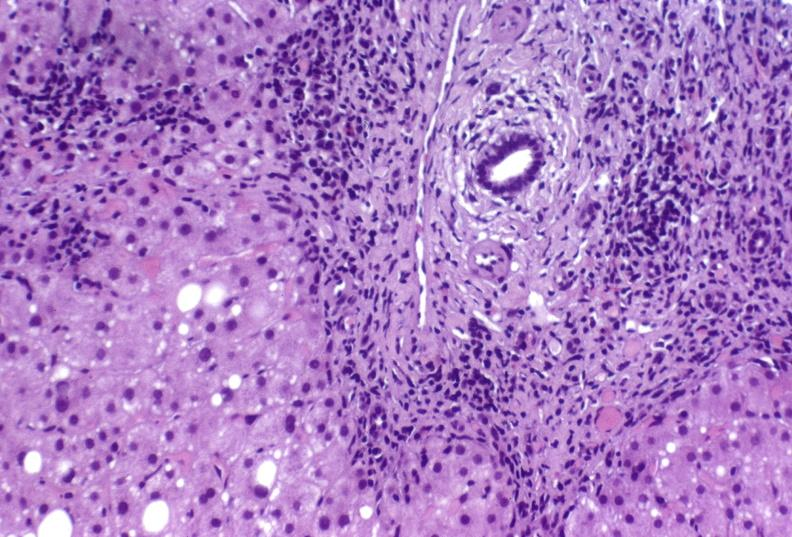what is present?
Answer the question using a single word or phrase. Liver 